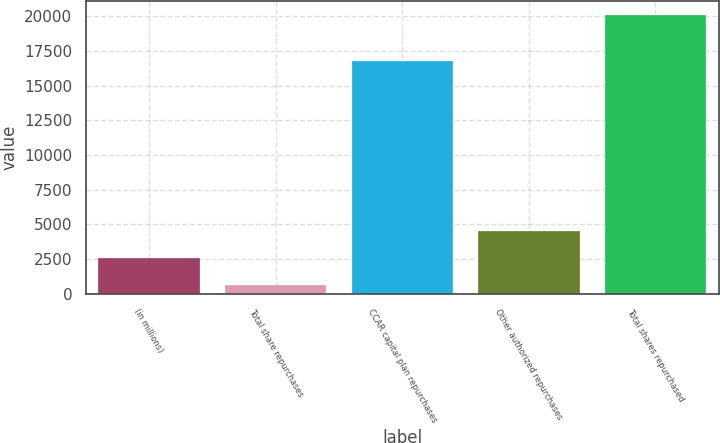<chart> <loc_0><loc_0><loc_500><loc_500><bar_chart><fcel>(in millions)<fcel>Total share repurchases<fcel>CCAR capital plan repurchases<fcel>Other authorized repurchases<fcel>Total shares repurchased<nl><fcel>2617.8<fcel>676<fcel>16754<fcel>4559.6<fcel>20094<nl></chart> 